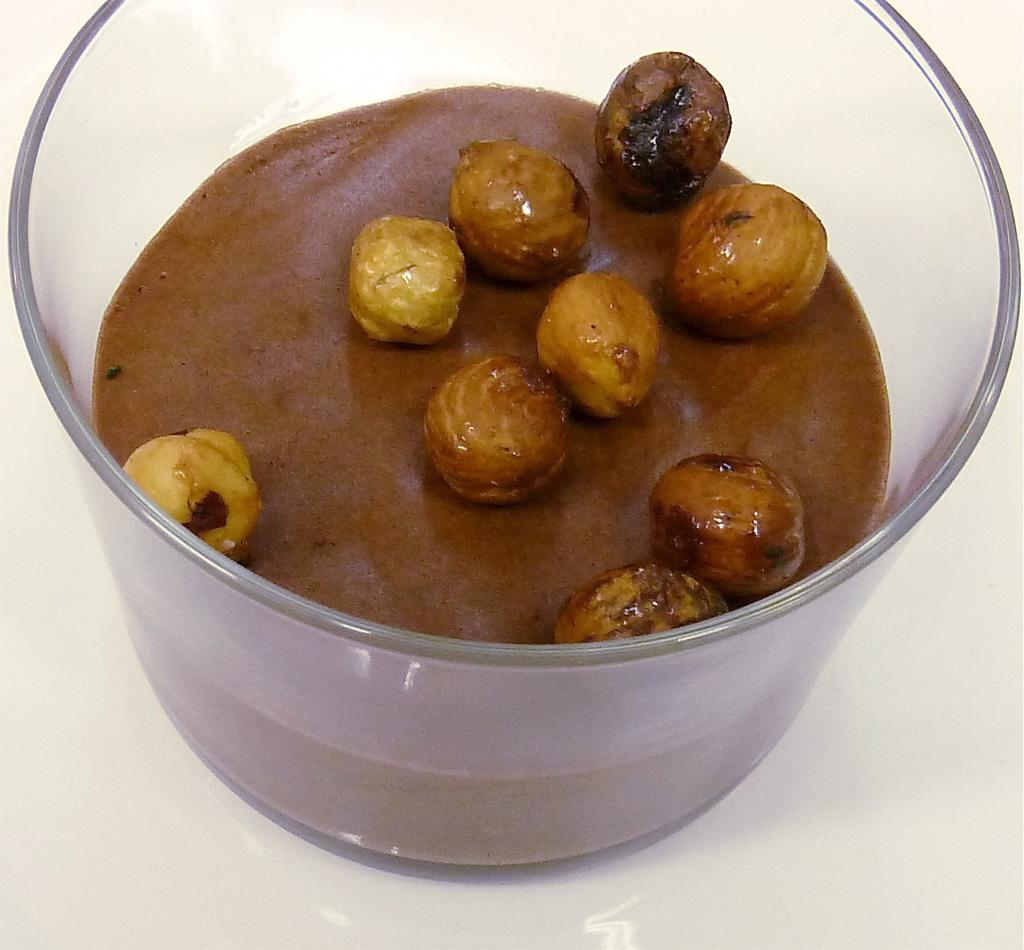What type of container is visible in the image? There is a glass bowl in the image. What is inside the glass bowl? The bowl contains food. What is the color of the food in the bowl? The food is brown in color. What type of note is attached to the food in the image? There is no note attached to the food in the image. 